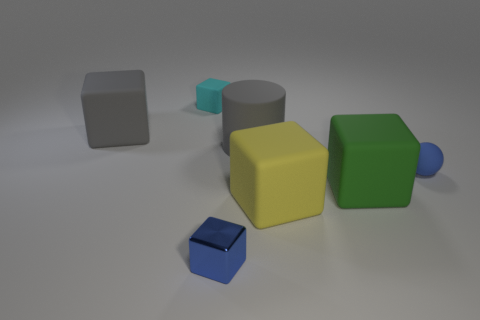There is a object that is the same color as the matte sphere; what size is it?
Offer a terse response. Small. What number of things are the same color as the matte cylinder?
Keep it short and to the point. 1. What material is the blue cube?
Make the answer very short. Metal. Is the yellow matte thing the same shape as the cyan object?
Provide a succinct answer. Yes. Is there a small green cylinder made of the same material as the blue ball?
Provide a short and direct response. No. The thing that is both behind the blue block and in front of the green matte block is what color?
Provide a succinct answer. Yellow. There is a small block that is in front of the gray cylinder; what is its material?
Make the answer very short. Metal. Is there a green thing of the same shape as the yellow matte thing?
Provide a succinct answer. Yes. How many other things are there of the same shape as the blue rubber thing?
Offer a very short reply. 0. Does the big yellow object have the same shape as the big gray matte thing on the left side of the tiny cyan rubber block?
Provide a short and direct response. Yes. 